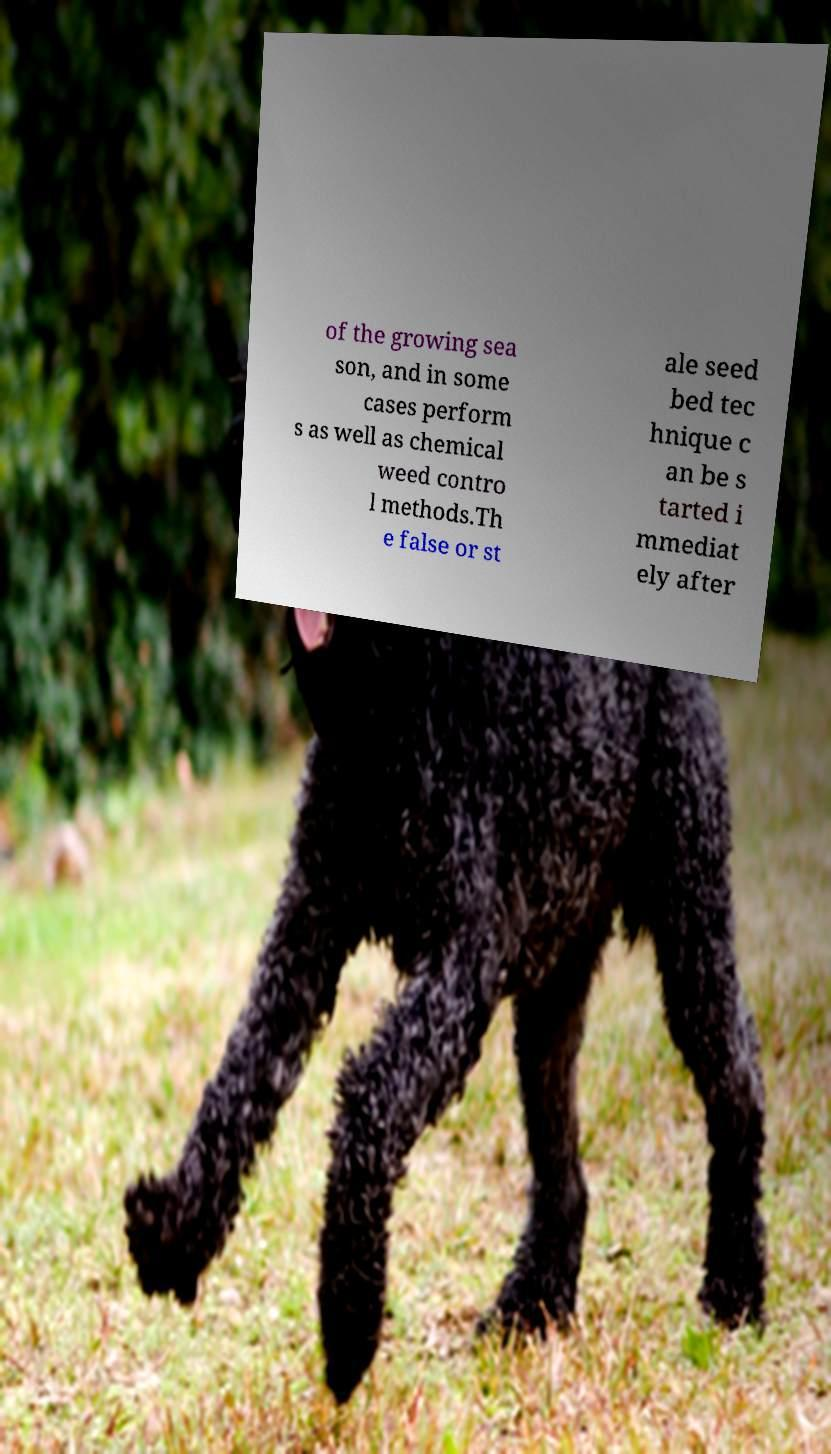There's text embedded in this image that I need extracted. Can you transcribe it verbatim? of the growing sea son, and in some cases perform s as well as chemical weed contro l methods.Th e false or st ale seed bed tec hnique c an be s tarted i mmediat ely after 